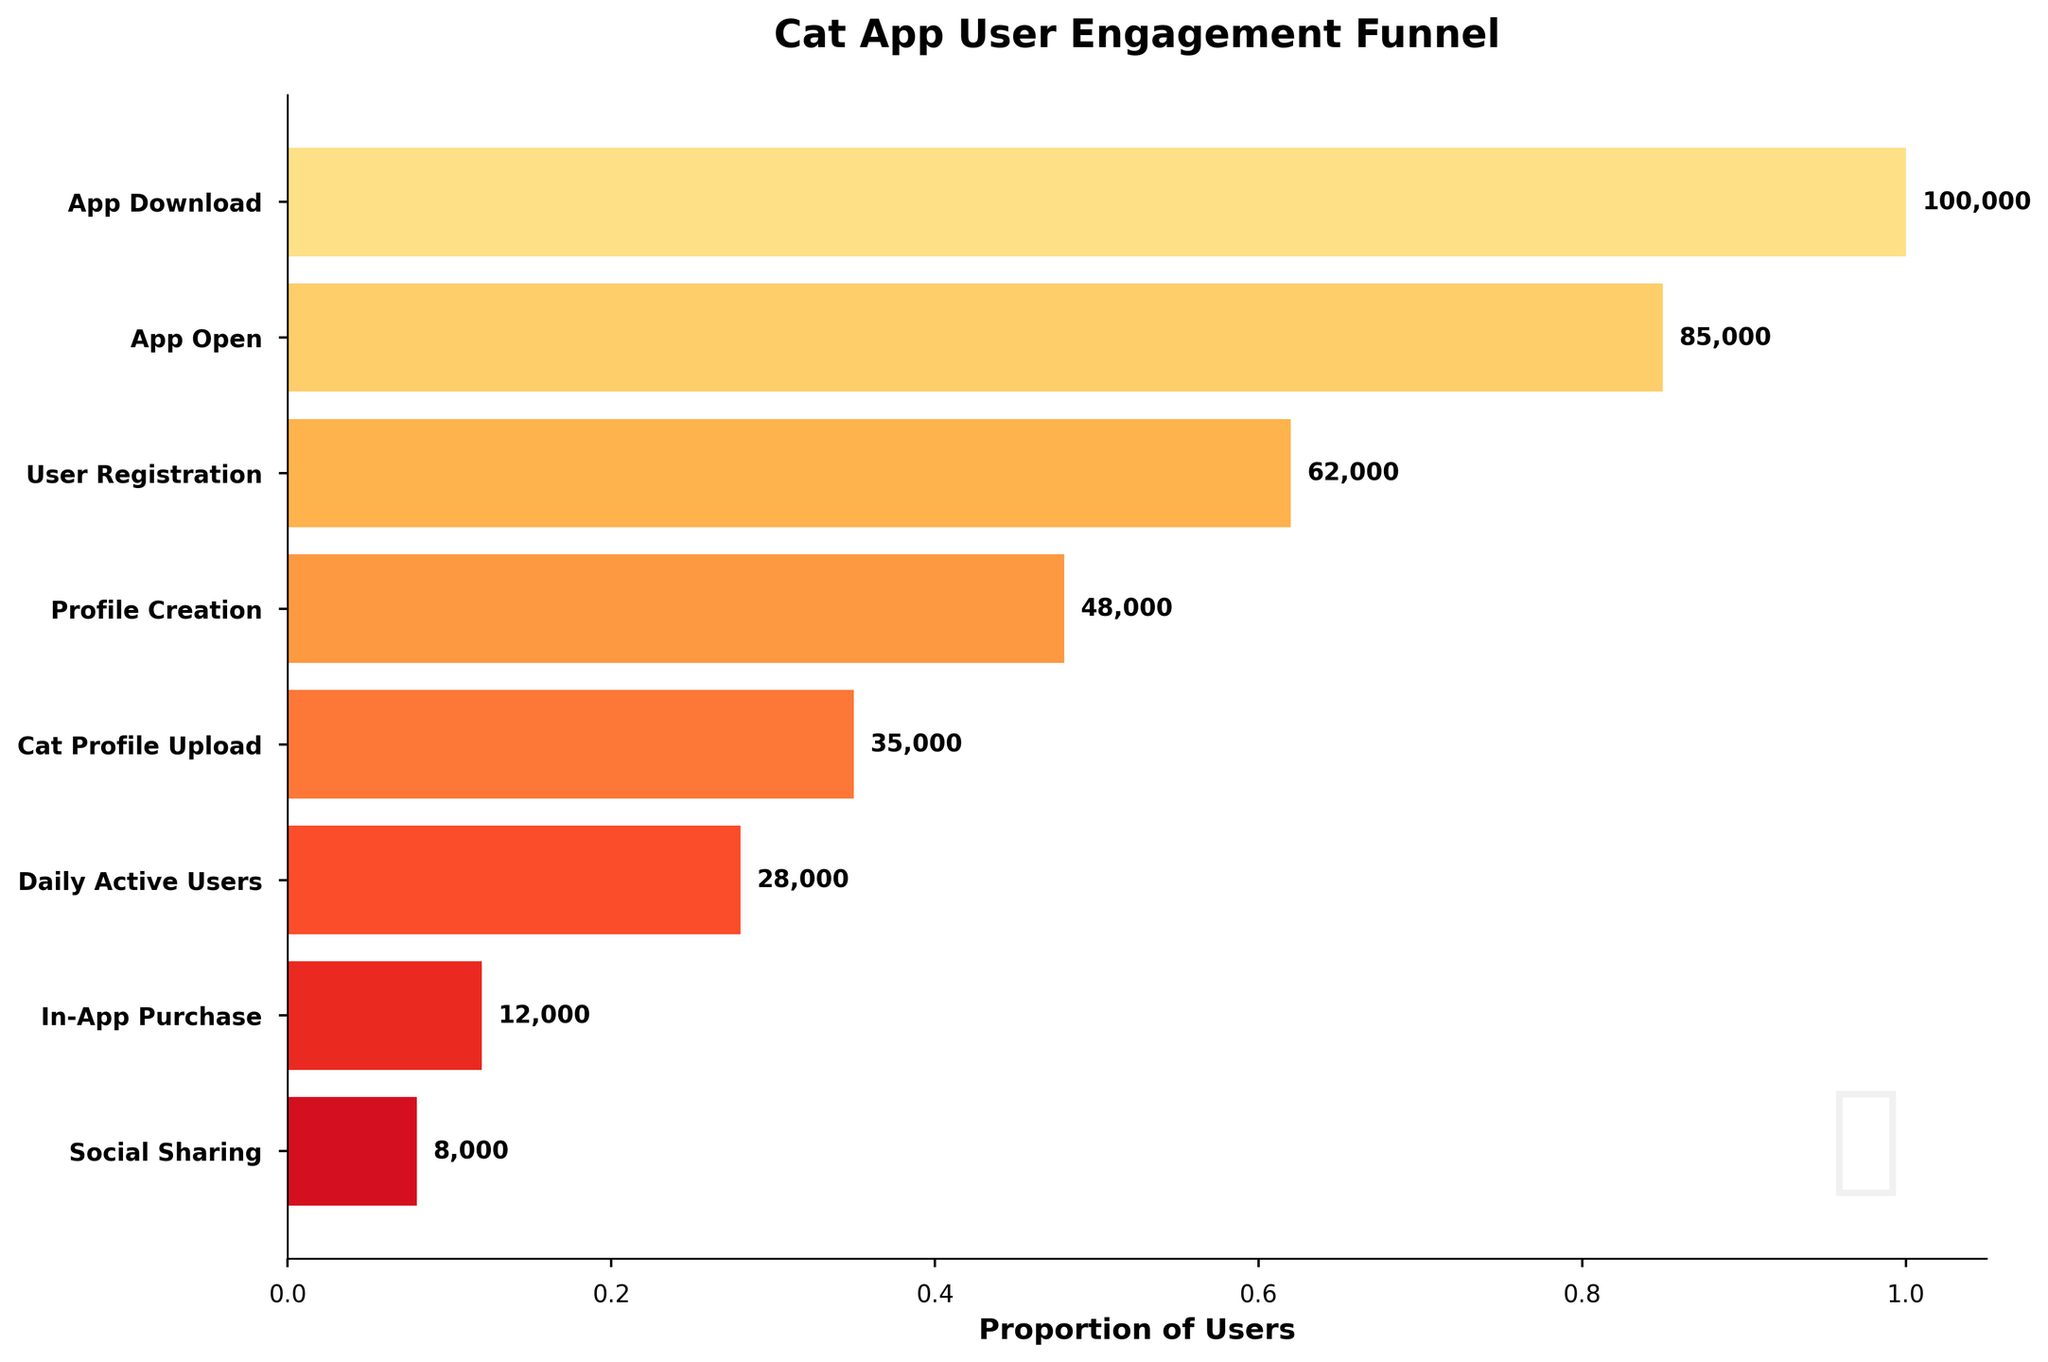how many stages are there in the funnel? Count the number of unique stages listed in the y-axis labels. There are 8 stages: App Download, App Open, User Registration, Profile Creation, Cat Profile Upload, Daily Active Users, In-App Purchase, Social Sharing.
Answer: 8 At which stage do the user numbers drop below 50,000? Identify the user count at each stage and find the first stage below 50,000 users. The user count is 48,000 at the Profile Creation stage.
Answer: Profile Creation What is the title of the funnel chart? The title is clearly written at the top of the chart. It says "Cat App User Engagement Funnel".
Answer: Cat App User Engagement Funnel Which stage has the second-highest number of users? First, find the highest user count, which is at the App Download stage. The second-highest count is 85,000 users at the App Open stage.
Answer: App Open What's the total number of users at the User Registration and In-App Purchase stages? Add the number of users at these stages: 62,000 (User Registration) + 12,000 (In-App Purchase) = 74,000.
Answer: 74,000 What's the percentage drop from App Download to User Registration? Calculate the difference: 100,000 (App Download) - 62,000 (User Registration) = 38,000. Then, find the percentage: (38,000 / 100,000) * 100 = 38%.
Answer: 38% How many more users are there at Profile Creation than at Daily Active Users? Find the difference between the two: 48,000 (Profile Creation) - 28,000 (Daily Active Users) = 20,000.
Answer: 20,000 Which stage sees the highest percentage drop in user numbers? First, calculate the percentage drop for each stage, then compare. The highest percentage drop is between User Registration (62,000) and Profile Creation (48,000). The drop is 14,000, which is approximately 22.6% of 62,000.
Answer: Profile Creation In terms of user retention, which stage represents about two-thirds of the App Download users? Find the stage where the user count is around 66,667 (which is 2/3 of 100,000). The closest number is 62,000 users at User Registration.
Answer: User Registration 